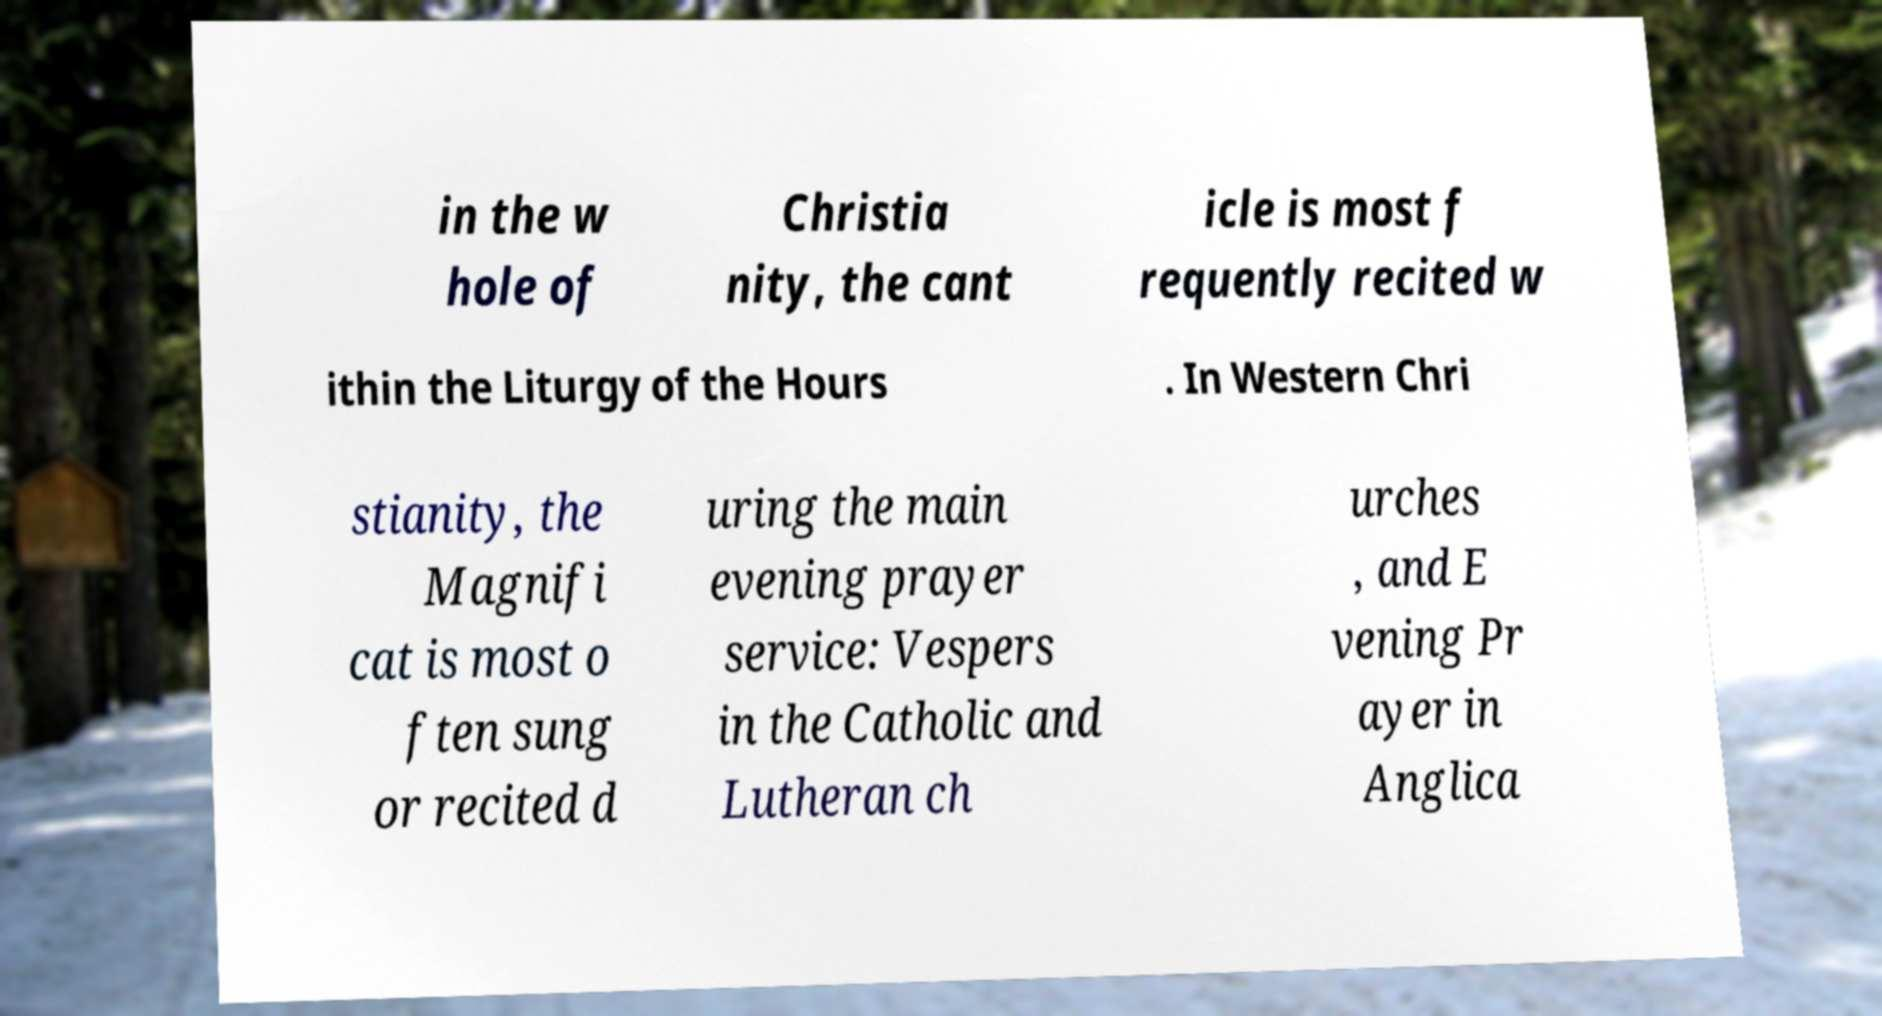Can you accurately transcribe the text from the provided image for me? in the w hole of Christia nity, the cant icle is most f requently recited w ithin the Liturgy of the Hours . In Western Chri stianity, the Magnifi cat is most o ften sung or recited d uring the main evening prayer service: Vespers in the Catholic and Lutheran ch urches , and E vening Pr ayer in Anglica 